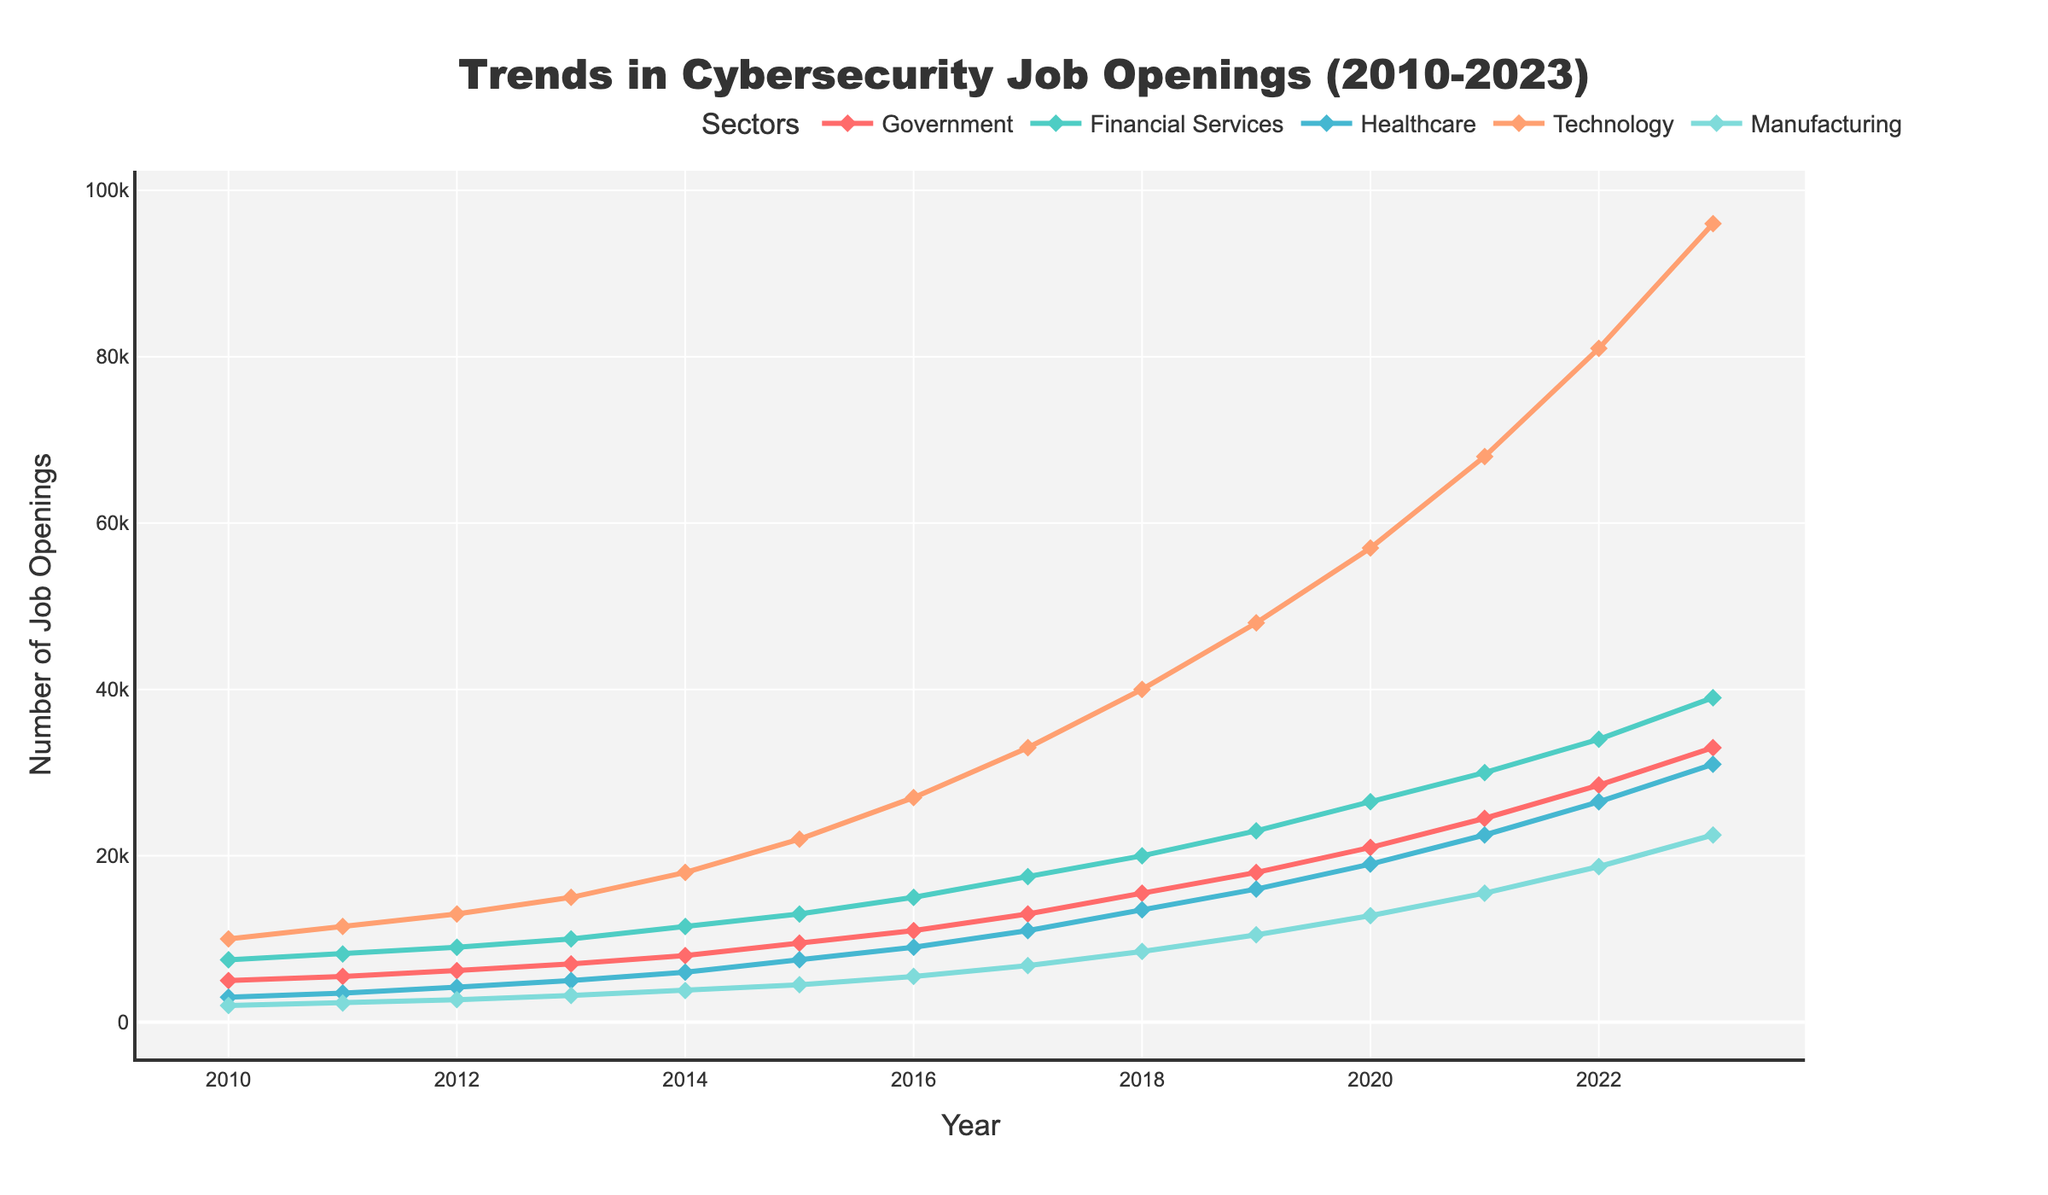Which sector had the highest number of job openings in 2018? In the chart, look for the highest point in the year 2018 across all sectors' lines. The 'Technology' sector had the highest point compared to others.
Answer: Technology How did the number of job openings in the Healthcare sector change from 2015 to 2021? Referring to the lines corresponding to the Healthcare sector, in 2015 there were 7,500 openings and in 2021 there were 22,500 openings. The change is 22,500 - 7,500 = 15,000.
Answer: Increased by 15,000 By how much did the job openings in Manufacturing increase from 2010 to 2023? Looking at the start (2010) and end (2023) points for the Manufacturing sector, the data shows 2,000 openings in 2010 and 22,500 in 2023. The increase is 22,500 - 2,000 = 20,500.
Answer: Increased by 20,500 Which sector saw the steepest increase in job openings between 2010 and 2023? The steepest increase can be determined by examining the slope of each sector's line. The Technology sector shows the most dramatic rise from 10,000 in 2010 to 96,000 in 2023.
Answer: Technology In which year did Financial Services surpass the 20,000 job openings mark? Tracking the Financial Services line, it crosses the 20,000 mark between 2017 and 2018.
Answer: 2018 What is the average number of job openings in the Government sector from 2010 to 2023? Sum the values for each year (5000 + 5500 + 6200 + 7000 + 8000 + 9500 + 11000 + 13000 + 15500 + 18000 + 21000 + 24500 + 28500 + 33000) = 163700; then divide by the number of years (14). The average is 163700/14 ≈ 11,693.
Answer: 11,693 Did the Healthcare sector ever have more job openings than the Financial Services sector? Reviewing the lines for Healthcare and Financial Services across all years, there is no instance where Healthcare surpassed Financial Services.
Answer: No How many more job openings were there in Technology compared to Manufacturing in 2023? In 2023, Technology had 96,000 openings, and Manufacturing had 22,500. The difference is 96,000 - 22,500 = 73,500.
Answer: 73,500 Which sector reached the 30,000 job openings mark first, and in which year? Observing the chart, Technology reached the 30,000 mark before any other sector, in the year 2017.
Answer: Technology, 2017 